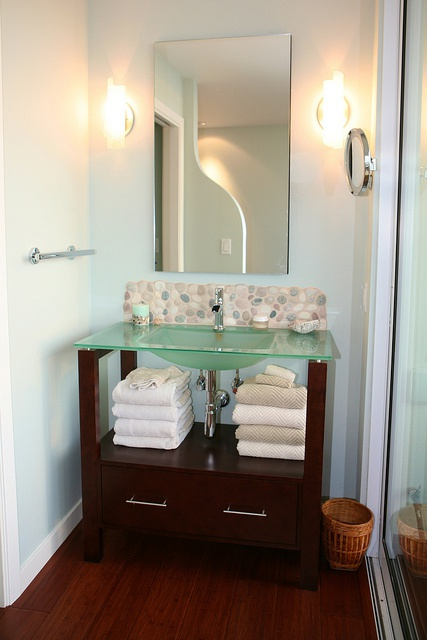Describe the objects in this image and their specific colors. I can see a sink in tan, darkgray, teal, turquoise, and gray tones in this image. 